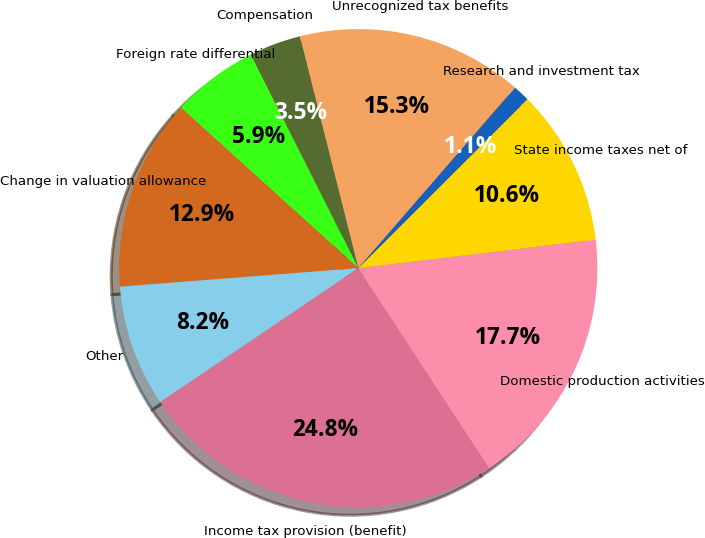Convert chart to OTSL. <chart><loc_0><loc_0><loc_500><loc_500><pie_chart><fcel>Income tax provision (benefit)<fcel>Domestic production activities<fcel>State income taxes net of<fcel>Research and investment tax<fcel>Unrecognized tax benefits<fcel>Compensation<fcel>Foreign rate differential<fcel>Change in valuation allowance<fcel>Other<nl><fcel>24.77%<fcel>17.68%<fcel>10.59%<fcel>1.13%<fcel>15.31%<fcel>3.5%<fcel>5.86%<fcel>12.95%<fcel>8.22%<nl></chart> 